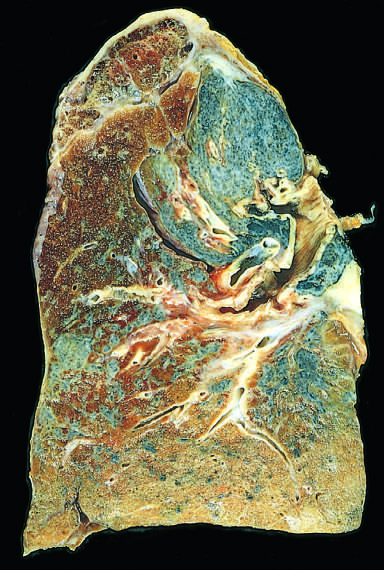has the palisade of cartilage contracted the upper lobe into a small dark mass?
Answer the question using a single word or phrase. No 